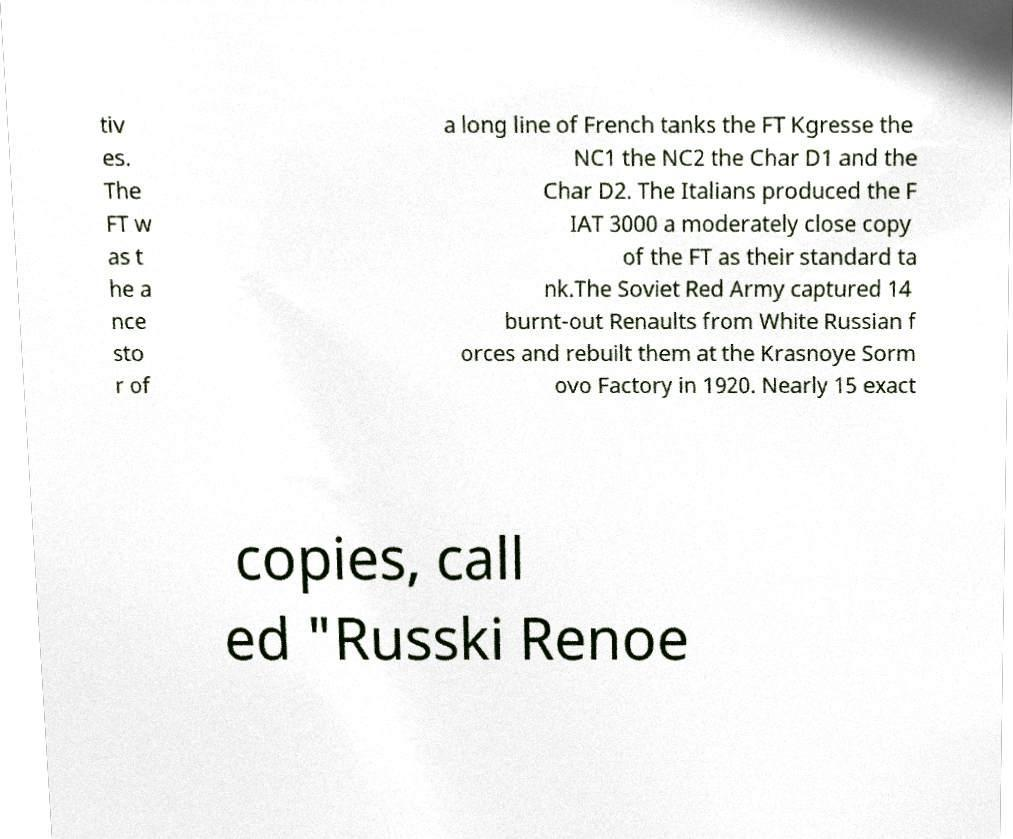I need the written content from this picture converted into text. Can you do that? tiv es. The FT w as t he a nce sto r of a long line of French tanks the FT Kgresse the NC1 the NC2 the Char D1 and the Char D2. The Italians produced the F IAT 3000 a moderately close copy of the FT as their standard ta nk.The Soviet Red Army captured 14 burnt-out Renaults from White Russian f orces and rebuilt them at the Krasnoye Sorm ovo Factory in 1920. Nearly 15 exact copies, call ed "Russki Renoe 